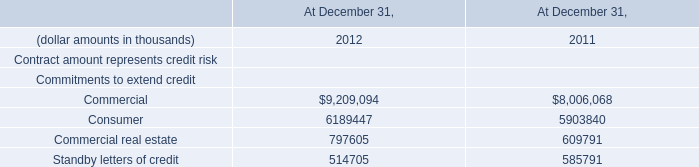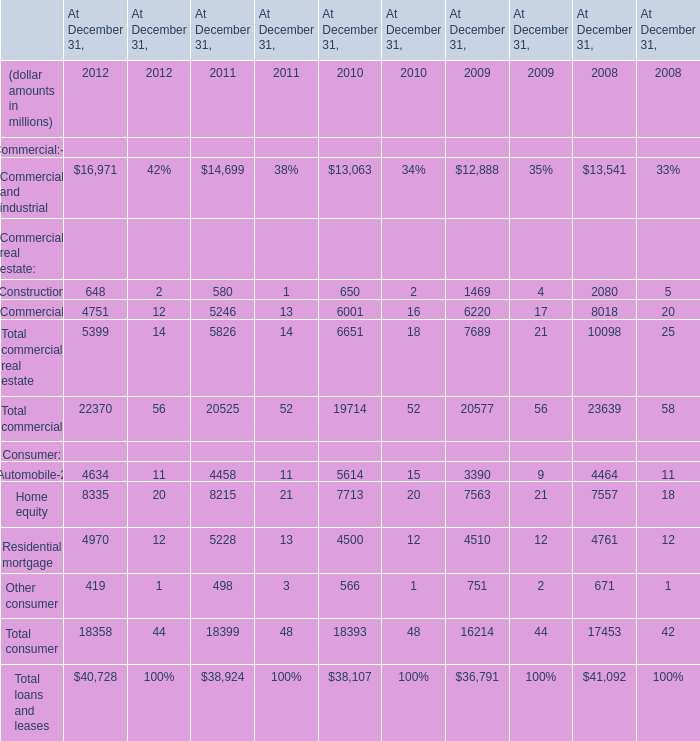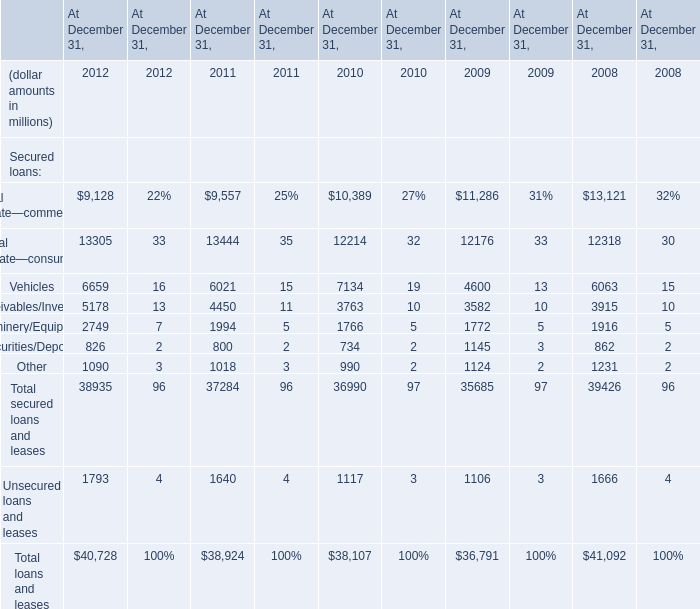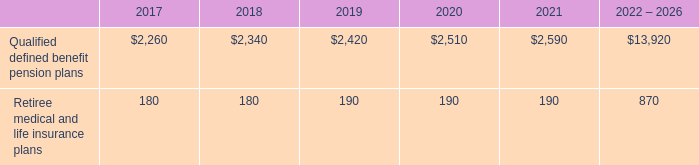What is the sum of Secured loans in 2012? (in million) 
Computations: ((((((9128 + 13305) + 6659) + 5178) + 2749) + 826) + 1090)
Answer: 38935.0. 